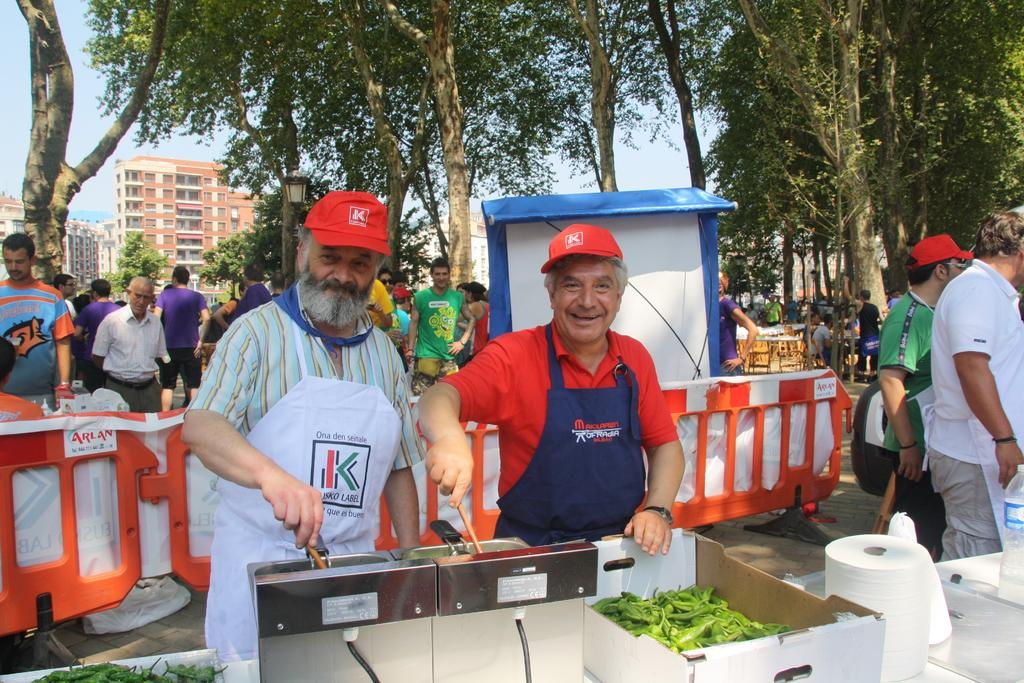What are the people in front of the image doing? The people in front are cooking. Can you describe the people standing at the back of the image? There are other people standing at the back of the image. What type of natural environment is visible in the image? There are many trees visible in the image. What structures can be seen behind the trees? There are buildings behind the trees. What type of selection process is being conducted by the ducks in the image? There are no ducks present in the image, so no selection process can be observed. 